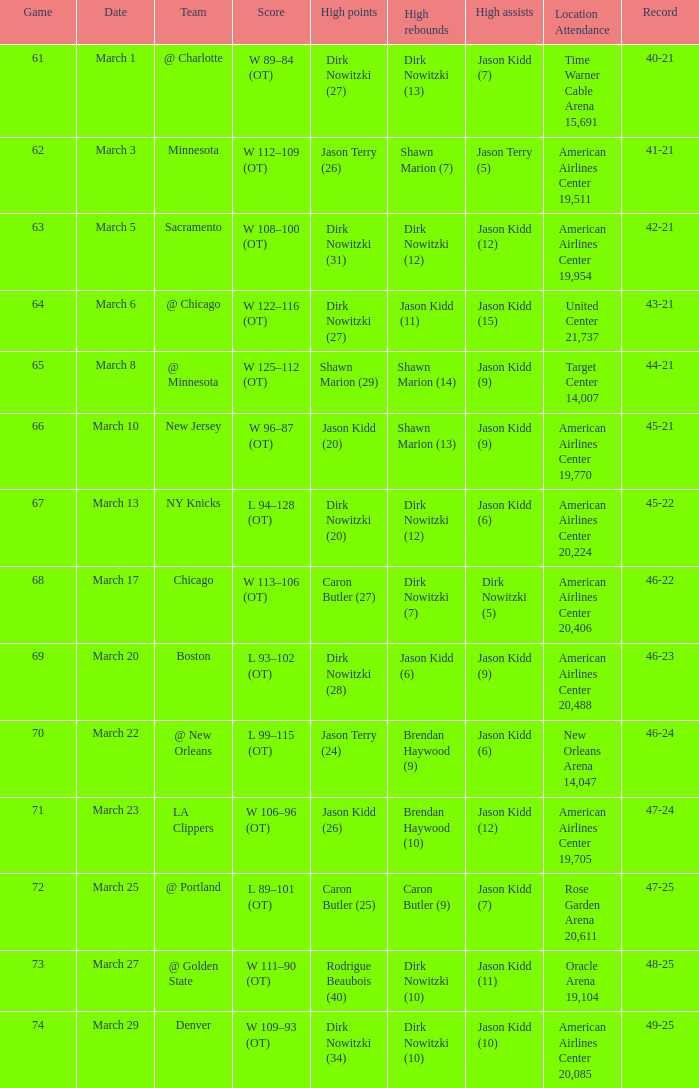Can you provide the stadium name and the number of attendees during the match when the team had a 45-22 score? 1.0. 